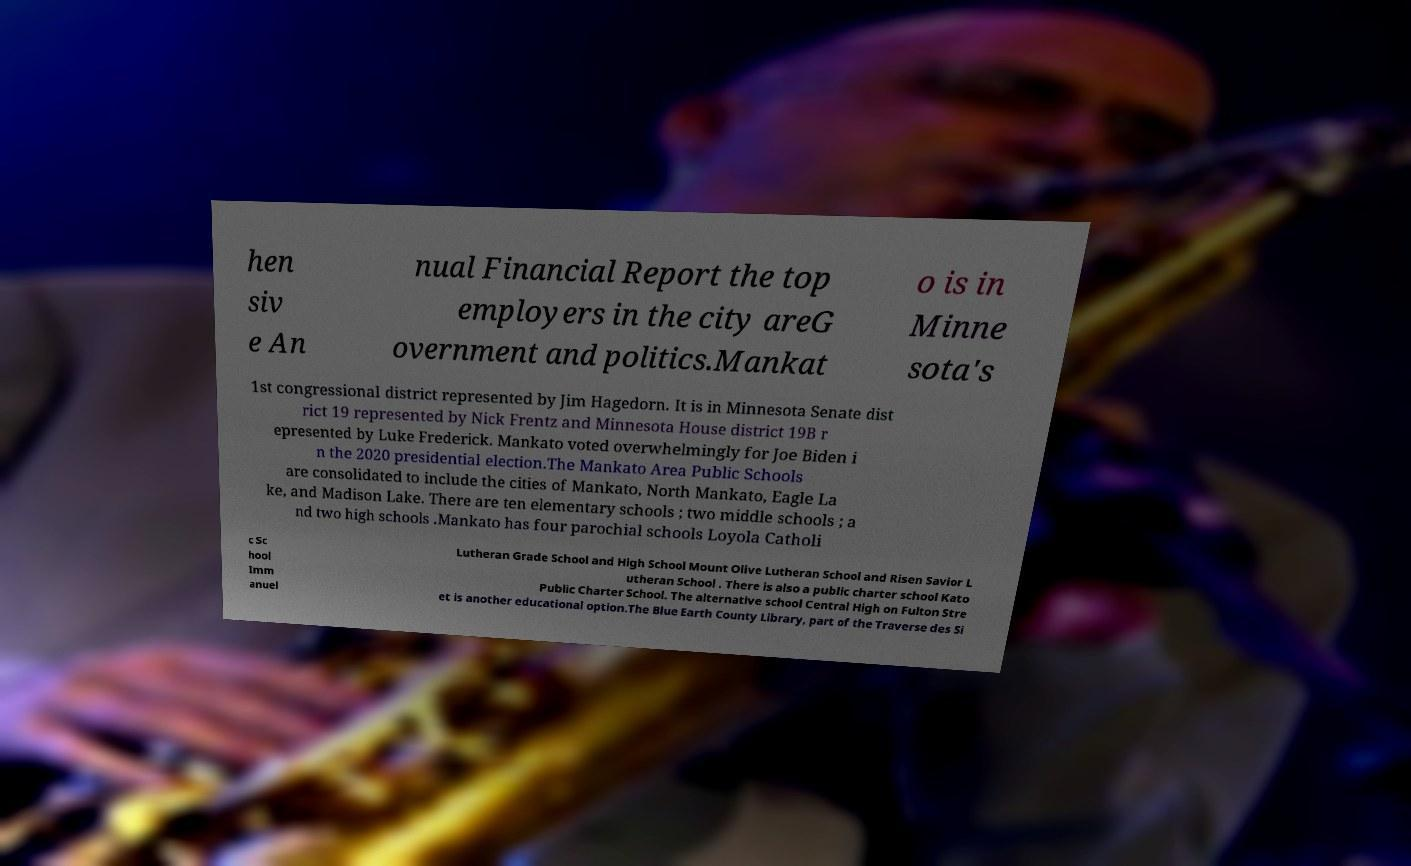Can you read and provide the text displayed in the image?This photo seems to have some interesting text. Can you extract and type it out for me? hen siv e An nual Financial Report the top employers in the city areG overnment and politics.Mankat o is in Minne sota's 1st congressional district represented by Jim Hagedorn. It is in Minnesota Senate dist rict 19 represented by Nick Frentz and Minnesota House district 19B r epresented by Luke Frederick. Mankato voted overwhelmingly for Joe Biden i n the 2020 presidential election.The Mankato Area Public Schools are consolidated to include the cities of Mankato, North Mankato, Eagle La ke, and Madison Lake. There are ten elementary schools ; two middle schools ; a nd two high schools .Mankato has four parochial schools Loyola Catholi c Sc hool Imm anuel Lutheran Grade School and High School Mount Olive Lutheran School and Risen Savior L utheran School . There is also a public charter school Kato Public Charter School. The alternative school Central High on Fulton Stre et is another educational option.The Blue Earth County Library, part of the Traverse des Si 